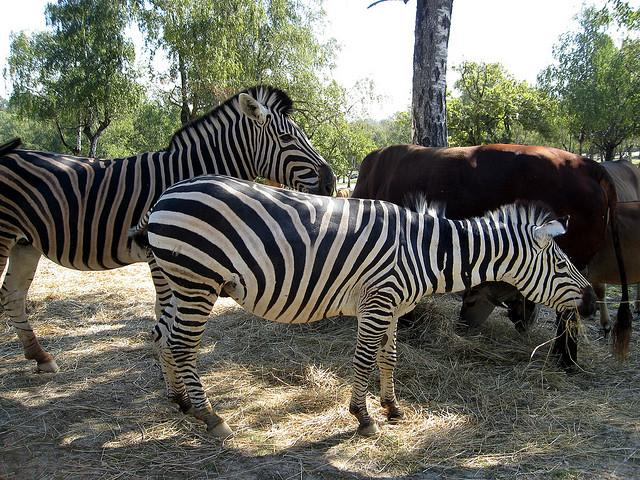Where are the animals? zoo 